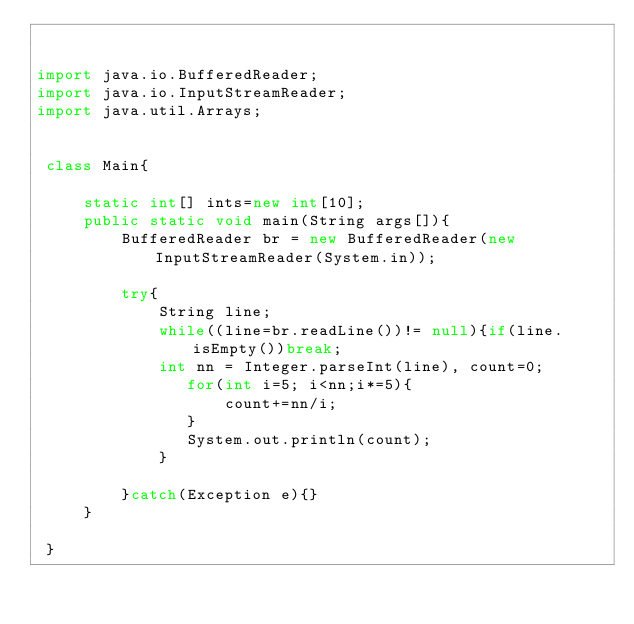<code> <loc_0><loc_0><loc_500><loc_500><_Java_>

import java.io.BufferedReader;
import java.io.InputStreamReader;
import java.util.Arrays;
 

 class Main{
             
     static int[] ints=new int[10];
     public static void main(String args[]){
         BufferedReader br = new BufferedReader(new InputStreamReader(System.in));
         
         try{
             String line;
             while((line=br.readLine())!= null){if(line.isEmpty())break;
             int nn = Integer.parseInt(line), count=0;
                for(int i=5; i<nn;i*=5){
                    count+=nn/i;
                }
                System.out.println(count);
             }
             
         }catch(Exception e){}         
     }
   
 }</code> 